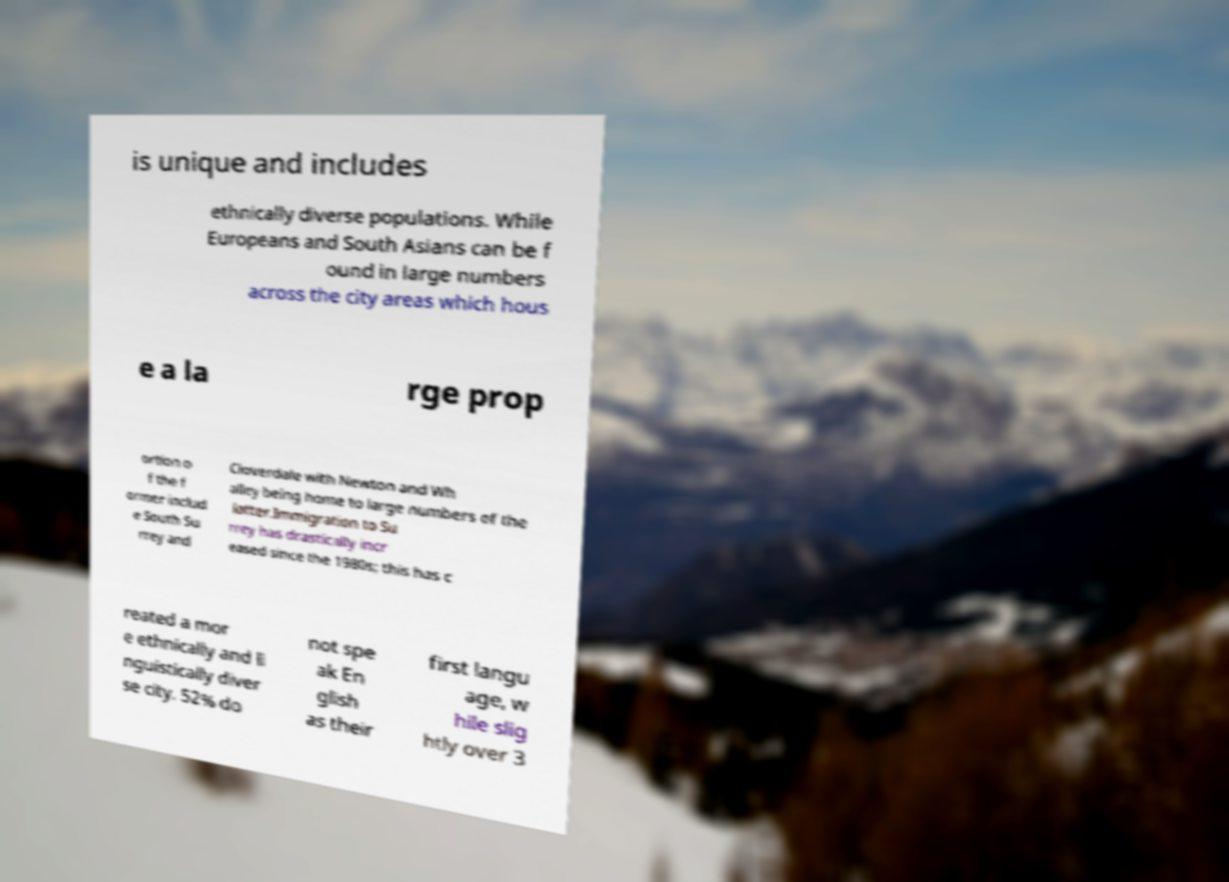Could you extract and type out the text from this image? is unique and includes ethnically diverse populations. While Europeans and South Asians can be f ound in large numbers across the city areas which hous e a la rge prop ortion o f the f ormer includ e South Su rrey and Cloverdale with Newton and Wh alley being home to large numbers of the latter.Immigration to Su rrey has drastically incr eased since the 1980s; this has c reated a mor e ethnically and li nguistically diver se city. 52% do not spe ak En glish as their first langu age, w hile slig htly over 3 